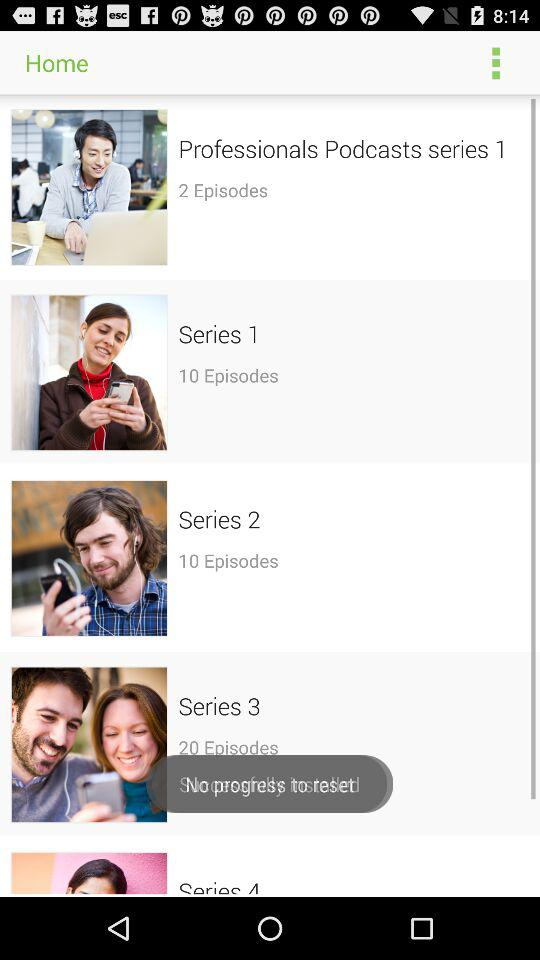How many episodes are there in "Professionals Podcasts series 1"? There are 2 episodes. 